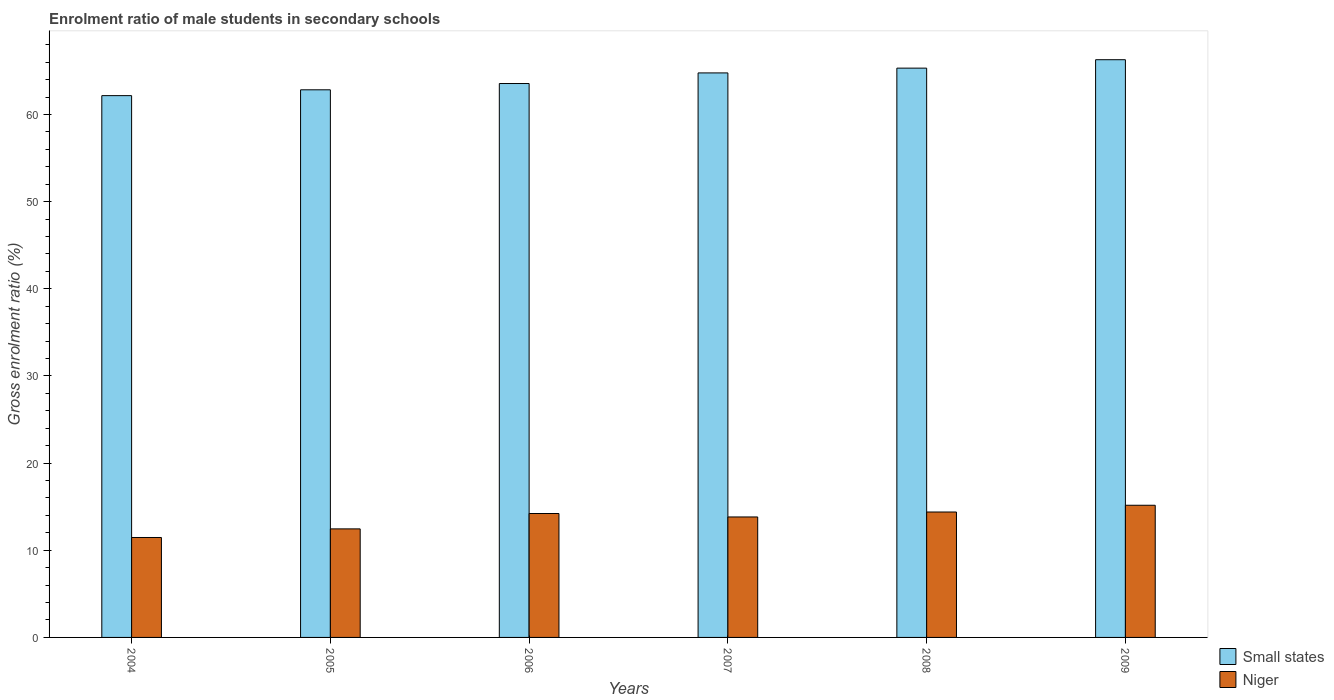Are the number of bars on each tick of the X-axis equal?
Keep it short and to the point. Yes. How many bars are there on the 3rd tick from the left?
Your answer should be very brief. 2. In how many cases, is the number of bars for a given year not equal to the number of legend labels?
Give a very brief answer. 0. What is the enrolment ratio of male students in secondary schools in Niger in 2006?
Your answer should be very brief. 14.22. Across all years, what is the maximum enrolment ratio of male students in secondary schools in Small states?
Keep it short and to the point. 66.29. Across all years, what is the minimum enrolment ratio of male students in secondary schools in Small states?
Offer a very short reply. 62.17. In which year was the enrolment ratio of male students in secondary schools in Small states maximum?
Your answer should be compact. 2009. What is the total enrolment ratio of male students in secondary schools in Small states in the graph?
Keep it short and to the point. 384.98. What is the difference between the enrolment ratio of male students in secondary schools in Niger in 2004 and that in 2008?
Your answer should be compact. -2.92. What is the difference between the enrolment ratio of male students in secondary schools in Small states in 2005 and the enrolment ratio of male students in secondary schools in Niger in 2009?
Your response must be concise. 47.67. What is the average enrolment ratio of male students in secondary schools in Niger per year?
Keep it short and to the point. 13.59. In the year 2006, what is the difference between the enrolment ratio of male students in secondary schools in Niger and enrolment ratio of male students in secondary schools in Small states?
Your response must be concise. -49.34. What is the ratio of the enrolment ratio of male students in secondary schools in Niger in 2005 to that in 2007?
Your answer should be compact. 0.9. Is the enrolment ratio of male students in secondary schools in Small states in 2005 less than that in 2009?
Give a very brief answer. Yes. What is the difference between the highest and the second highest enrolment ratio of male students in secondary schools in Small states?
Your response must be concise. 0.97. What is the difference between the highest and the lowest enrolment ratio of male students in secondary schools in Small states?
Offer a very short reply. 4.12. Is the sum of the enrolment ratio of male students in secondary schools in Small states in 2004 and 2005 greater than the maximum enrolment ratio of male students in secondary schools in Niger across all years?
Your response must be concise. Yes. What does the 2nd bar from the left in 2005 represents?
Your answer should be compact. Niger. What does the 2nd bar from the right in 2009 represents?
Provide a succinct answer. Small states. How many bars are there?
Ensure brevity in your answer.  12. How many years are there in the graph?
Keep it short and to the point. 6. Does the graph contain any zero values?
Provide a short and direct response. No. Does the graph contain grids?
Your answer should be compact. No. How are the legend labels stacked?
Your answer should be compact. Vertical. What is the title of the graph?
Offer a terse response. Enrolment ratio of male students in secondary schools. What is the label or title of the X-axis?
Ensure brevity in your answer.  Years. What is the Gross enrolment ratio (%) of Small states in 2004?
Your answer should be compact. 62.17. What is the Gross enrolment ratio (%) in Niger in 2004?
Keep it short and to the point. 11.47. What is the Gross enrolment ratio (%) of Small states in 2005?
Give a very brief answer. 62.84. What is the Gross enrolment ratio (%) in Niger in 2005?
Provide a short and direct response. 12.46. What is the Gross enrolment ratio (%) of Small states in 2006?
Your answer should be very brief. 63.56. What is the Gross enrolment ratio (%) of Niger in 2006?
Ensure brevity in your answer.  14.22. What is the Gross enrolment ratio (%) of Small states in 2007?
Your response must be concise. 64.78. What is the Gross enrolment ratio (%) of Niger in 2007?
Offer a terse response. 13.82. What is the Gross enrolment ratio (%) of Small states in 2008?
Ensure brevity in your answer.  65.33. What is the Gross enrolment ratio (%) of Niger in 2008?
Keep it short and to the point. 14.39. What is the Gross enrolment ratio (%) of Small states in 2009?
Offer a very short reply. 66.29. What is the Gross enrolment ratio (%) of Niger in 2009?
Ensure brevity in your answer.  15.17. Across all years, what is the maximum Gross enrolment ratio (%) in Small states?
Keep it short and to the point. 66.29. Across all years, what is the maximum Gross enrolment ratio (%) in Niger?
Keep it short and to the point. 15.17. Across all years, what is the minimum Gross enrolment ratio (%) of Small states?
Give a very brief answer. 62.17. Across all years, what is the minimum Gross enrolment ratio (%) in Niger?
Provide a short and direct response. 11.47. What is the total Gross enrolment ratio (%) in Small states in the graph?
Your answer should be very brief. 384.98. What is the total Gross enrolment ratio (%) in Niger in the graph?
Your answer should be very brief. 81.53. What is the difference between the Gross enrolment ratio (%) in Small states in 2004 and that in 2005?
Your answer should be compact. -0.67. What is the difference between the Gross enrolment ratio (%) of Niger in 2004 and that in 2005?
Offer a very short reply. -0.99. What is the difference between the Gross enrolment ratio (%) in Small states in 2004 and that in 2006?
Offer a terse response. -1.39. What is the difference between the Gross enrolment ratio (%) of Niger in 2004 and that in 2006?
Offer a terse response. -2.75. What is the difference between the Gross enrolment ratio (%) of Small states in 2004 and that in 2007?
Offer a terse response. -2.61. What is the difference between the Gross enrolment ratio (%) in Niger in 2004 and that in 2007?
Provide a succinct answer. -2.36. What is the difference between the Gross enrolment ratio (%) in Small states in 2004 and that in 2008?
Make the answer very short. -3.16. What is the difference between the Gross enrolment ratio (%) in Niger in 2004 and that in 2008?
Give a very brief answer. -2.92. What is the difference between the Gross enrolment ratio (%) in Small states in 2004 and that in 2009?
Keep it short and to the point. -4.12. What is the difference between the Gross enrolment ratio (%) of Niger in 2004 and that in 2009?
Make the answer very short. -3.7. What is the difference between the Gross enrolment ratio (%) in Small states in 2005 and that in 2006?
Your answer should be very brief. -0.72. What is the difference between the Gross enrolment ratio (%) in Niger in 2005 and that in 2006?
Your response must be concise. -1.77. What is the difference between the Gross enrolment ratio (%) in Small states in 2005 and that in 2007?
Your answer should be compact. -1.94. What is the difference between the Gross enrolment ratio (%) of Niger in 2005 and that in 2007?
Give a very brief answer. -1.37. What is the difference between the Gross enrolment ratio (%) in Small states in 2005 and that in 2008?
Ensure brevity in your answer.  -2.49. What is the difference between the Gross enrolment ratio (%) of Niger in 2005 and that in 2008?
Keep it short and to the point. -1.94. What is the difference between the Gross enrolment ratio (%) of Small states in 2005 and that in 2009?
Keep it short and to the point. -3.45. What is the difference between the Gross enrolment ratio (%) in Niger in 2005 and that in 2009?
Keep it short and to the point. -2.71. What is the difference between the Gross enrolment ratio (%) of Small states in 2006 and that in 2007?
Keep it short and to the point. -1.22. What is the difference between the Gross enrolment ratio (%) of Niger in 2006 and that in 2007?
Your answer should be very brief. 0.4. What is the difference between the Gross enrolment ratio (%) in Small states in 2006 and that in 2008?
Offer a very short reply. -1.77. What is the difference between the Gross enrolment ratio (%) in Niger in 2006 and that in 2008?
Ensure brevity in your answer.  -0.17. What is the difference between the Gross enrolment ratio (%) of Small states in 2006 and that in 2009?
Make the answer very short. -2.73. What is the difference between the Gross enrolment ratio (%) of Niger in 2006 and that in 2009?
Your answer should be very brief. -0.95. What is the difference between the Gross enrolment ratio (%) of Small states in 2007 and that in 2008?
Your answer should be very brief. -0.55. What is the difference between the Gross enrolment ratio (%) in Niger in 2007 and that in 2008?
Your answer should be very brief. -0.57. What is the difference between the Gross enrolment ratio (%) of Small states in 2007 and that in 2009?
Ensure brevity in your answer.  -1.52. What is the difference between the Gross enrolment ratio (%) in Niger in 2007 and that in 2009?
Ensure brevity in your answer.  -1.34. What is the difference between the Gross enrolment ratio (%) of Small states in 2008 and that in 2009?
Give a very brief answer. -0.97. What is the difference between the Gross enrolment ratio (%) in Niger in 2008 and that in 2009?
Ensure brevity in your answer.  -0.77. What is the difference between the Gross enrolment ratio (%) of Small states in 2004 and the Gross enrolment ratio (%) of Niger in 2005?
Ensure brevity in your answer.  49.72. What is the difference between the Gross enrolment ratio (%) of Small states in 2004 and the Gross enrolment ratio (%) of Niger in 2006?
Your answer should be very brief. 47.95. What is the difference between the Gross enrolment ratio (%) in Small states in 2004 and the Gross enrolment ratio (%) in Niger in 2007?
Your response must be concise. 48.35. What is the difference between the Gross enrolment ratio (%) of Small states in 2004 and the Gross enrolment ratio (%) of Niger in 2008?
Offer a very short reply. 47.78. What is the difference between the Gross enrolment ratio (%) of Small states in 2004 and the Gross enrolment ratio (%) of Niger in 2009?
Offer a terse response. 47.01. What is the difference between the Gross enrolment ratio (%) of Small states in 2005 and the Gross enrolment ratio (%) of Niger in 2006?
Offer a terse response. 48.62. What is the difference between the Gross enrolment ratio (%) of Small states in 2005 and the Gross enrolment ratio (%) of Niger in 2007?
Give a very brief answer. 49.02. What is the difference between the Gross enrolment ratio (%) of Small states in 2005 and the Gross enrolment ratio (%) of Niger in 2008?
Keep it short and to the point. 48.45. What is the difference between the Gross enrolment ratio (%) of Small states in 2005 and the Gross enrolment ratio (%) of Niger in 2009?
Your answer should be compact. 47.67. What is the difference between the Gross enrolment ratio (%) of Small states in 2006 and the Gross enrolment ratio (%) of Niger in 2007?
Give a very brief answer. 49.74. What is the difference between the Gross enrolment ratio (%) in Small states in 2006 and the Gross enrolment ratio (%) in Niger in 2008?
Make the answer very short. 49.17. What is the difference between the Gross enrolment ratio (%) of Small states in 2006 and the Gross enrolment ratio (%) of Niger in 2009?
Your answer should be compact. 48.4. What is the difference between the Gross enrolment ratio (%) in Small states in 2007 and the Gross enrolment ratio (%) in Niger in 2008?
Keep it short and to the point. 50.39. What is the difference between the Gross enrolment ratio (%) in Small states in 2007 and the Gross enrolment ratio (%) in Niger in 2009?
Your answer should be very brief. 49.61. What is the difference between the Gross enrolment ratio (%) of Small states in 2008 and the Gross enrolment ratio (%) of Niger in 2009?
Your answer should be compact. 50.16. What is the average Gross enrolment ratio (%) in Small states per year?
Your answer should be very brief. 64.16. What is the average Gross enrolment ratio (%) of Niger per year?
Your answer should be very brief. 13.59. In the year 2004, what is the difference between the Gross enrolment ratio (%) in Small states and Gross enrolment ratio (%) in Niger?
Provide a short and direct response. 50.71. In the year 2005, what is the difference between the Gross enrolment ratio (%) of Small states and Gross enrolment ratio (%) of Niger?
Offer a terse response. 50.39. In the year 2006, what is the difference between the Gross enrolment ratio (%) in Small states and Gross enrolment ratio (%) in Niger?
Your answer should be compact. 49.34. In the year 2007, what is the difference between the Gross enrolment ratio (%) in Small states and Gross enrolment ratio (%) in Niger?
Provide a short and direct response. 50.95. In the year 2008, what is the difference between the Gross enrolment ratio (%) of Small states and Gross enrolment ratio (%) of Niger?
Your answer should be very brief. 50.94. In the year 2009, what is the difference between the Gross enrolment ratio (%) of Small states and Gross enrolment ratio (%) of Niger?
Keep it short and to the point. 51.13. What is the ratio of the Gross enrolment ratio (%) of Niger in 2004 to that in 2005?
Offer a terse response. 0.92. What is the ratio of the Gross enrolment ratio (%) in Small states in 2004 to that in 2006?
Provide a succinct answer. 0.98. What is the ratio of the Gross enrolment ratio (%) in Niger in 2004 to that in 2006?
Make the answer very short. 0.81. What is the ratio of the Gross enrolment ratio (%) in Small states in 2004 to that in 2007?
Provide a succinct answer. 0.96. What is the ratio of the Gross enrolment ratio (%) of Niger in 2004 to that in 2007?
Make the answer very short. 0.83. What is the ratio of the Gross enrolment ratio (%) in Small states in 2004 to that in 2008?
Keep it short and to the point. 0.95. What is the ratio of the Gross enrolment ratio (%) of Niger in 2004 to that in 2008?
Make the answer very short. 0.8. What is the ratio of the Gross enrolment ratio (%) of Small states in 2004 to that in 2009?
Keep it short and to the point. 0.94. What is the ratio of the Gross enrolment ratio (%) of Niger in 2004 to that in 2009?
Offer a terse response. 0.76. What is the ratio of the Gross enrolment ratio (%) of Niger in 2005 to that in 2006?
Offer a very short reply. 0.88. What is the ratio of the Gross enrolment ratio (%) in Small states in 2005 to that in 2007?
Offer a terse response. 0.97. What is the ratio of the Gross enrolment ratio (%) in Niger in 2005 to that in 2007?
Your answer should be compact. 0.9. What is the ratio of the Gross enrolment ratio (%) of Small states in 2005 to that in 2008?
Ensure brevity in your answer.  0.96. What is the ratio of the Gross enrolment ratio (%) in Niger in 2005 to that in 2008?
Provide a short and direct response. 0.87. What is the ratio of the Gross enrolment ratio (%) in Small states in 2005 to that in 2009?
Offer a very short reply. 0.95. What is the ratio of the Gross enrolment ratio (%) of Niger in 2005 to that in 2009?
Provide a short and direct response. 0.82. What is the ratio of the Gross enrolment ratio (%) of Small states in 2006 to that in 2007?
Your answer should be very brief. 0.98. What is the ratio of the Gross enrolment ratio (%) in Niger in 2006 to that in 2007?
Your answer should be very brief. 1.03. What is the ratio of the Gross enrolment ratio (%) in Small states in 2006 to that in 2008?
Offer a terse response. 0.97. What is the ratio of the Gross enrolment ratio (%) of Niger in 2006 to that in 2008?
Provide a short and direct response. 0.99. What is the ratio of the Gross enrolment ratio (%) of Small states in 2006 to that in 2009?
Provide a succinct answer. 0.96. What is the ratio of the Gross enrolment ratio (%) of Niger in 2006 to that in 2009?
Provide a succinct answer. 0.94. What is the ratio of the Gross enrolment ratio (%) in Niger in 2007 to that in 2008?
Your answer should be very brief. 0.96. What is the ratio of the Gross enrolment ratio (%) of Small states in 2007 to that in 2009?
Your answer should be compact. 0.98. What is the ratio of the Gross enrolment ratio (%) in Niger in 2007 to that in 2009?
Your response must be concise. 0.91. What is the ratio of the Gross enrolment ratio (%) in Small states in 2008 to that in 2009?
Your response must be concise. 0.99. What is the ratio of the Gross enrolment ratio (%) in Niger in 2008 to that in 2009?
Your answer should be very brief. 0.95. What is the difference between the highest and the second highest Gross enrolment ratio (%) of Small states?
Your answer should be very brief. 0.97. What is the difference between the highest and the second highest Gross enrolment ratio (%) of Niger?
Keep it short and to the point. 0.77. What is the difference between the highest and the lowest Gross enrolment ratio (%) of Small states?
Your response must be concise. 4.12. What is the difference between the highest and the lowest Gross enrolment ratio (%) of Niger?
Offer a terse response. 3.7. 